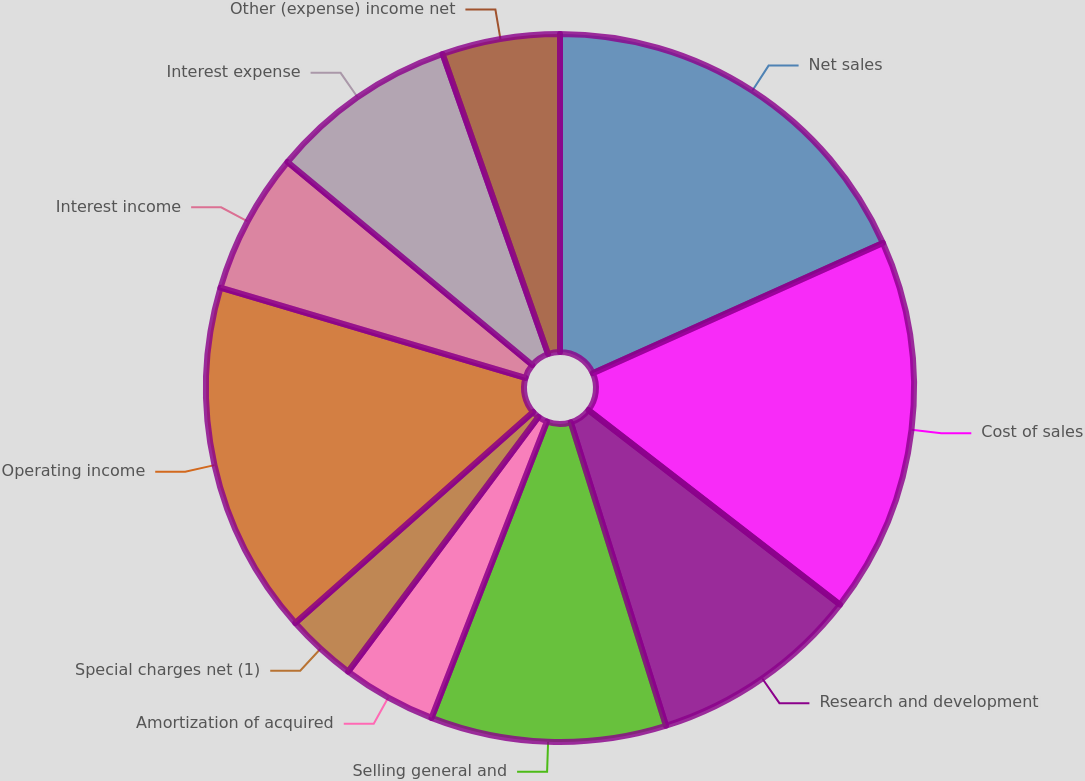Convert chart. <chart><loc_0><loc_0><loc_500><loc_500><pie_chart><fcel>Net sales<fcel>Cost of sales<fcel>Research and development<fcel>Selling general and<fcel>Amortization of acquired<fcel>Special charges net (1)<fcel>Operating income<fcel>Interest income<fcel>Interest expense<fcel>Other (expense) income net<nl><fcel>18.28%<fcel>17.2%<fcel>9.68%<fcel>10.75%<fcel>4.3%<fcel>3.23%<fcel>16.13%<fcel>6.45%<fcel>8.6%<fcel>5.38%<nl></chart> 